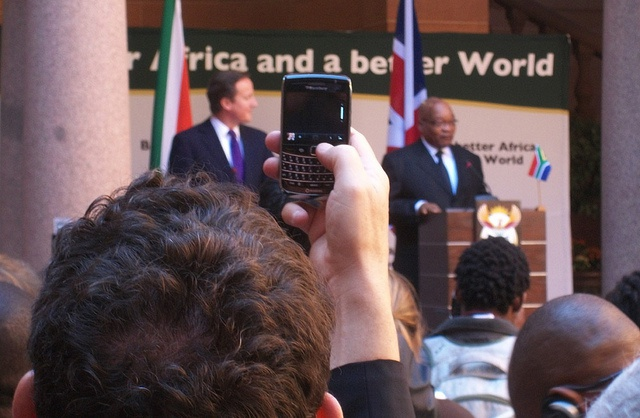Describe the objects in this image and their specific colors. I can see people in maroon, black, gray, and brown tones, people in maroon, black, and gray tones, people in maroon, black, lavender, gray, and lightblue tones, people in maroon, black, and brown tones, and cell phone in maroon, black, gray, and darkgray tones in this image. 